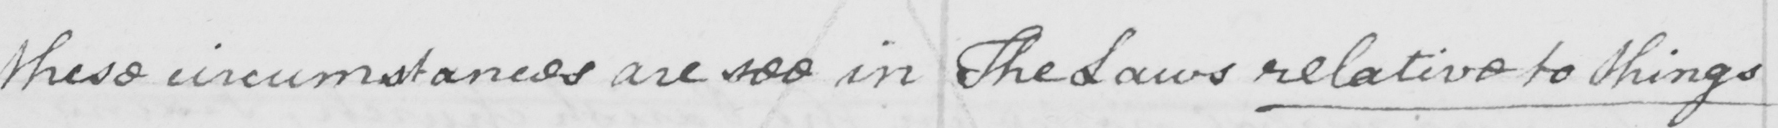What does this handwritten line say? these circumstances are see in The Laws relative to things 